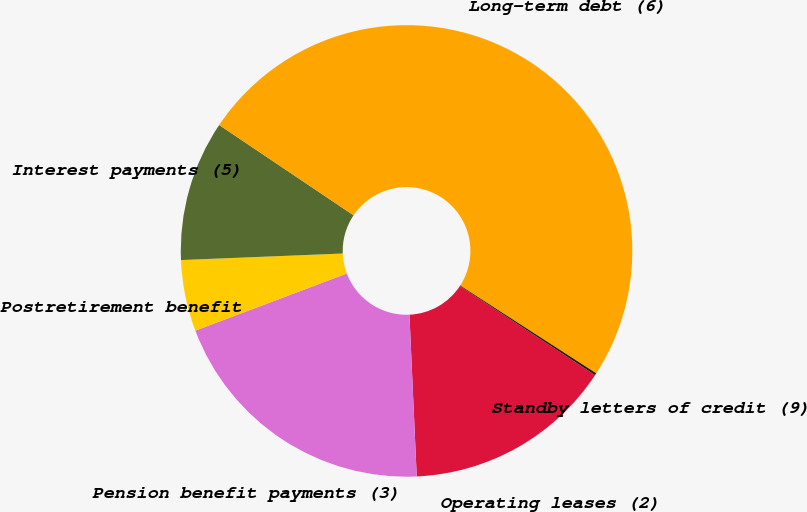<chart> <loc_0><loc_0><loc_500><loc_500><pie_chart><fcel>Operating leases (2)<fcel>Pension benefit payments (3)<fcel>Postretirement benefit<fcel>Interest payments (5)<fcel>Long-term debt (6)<fcel>Standby letters of credit (9)<nl><fcel>15.01%<fcel>19.97%<fcel>5.1%<fcel>10.06%<fcel>49.7%<fcel>0.15%<nl></chart> 